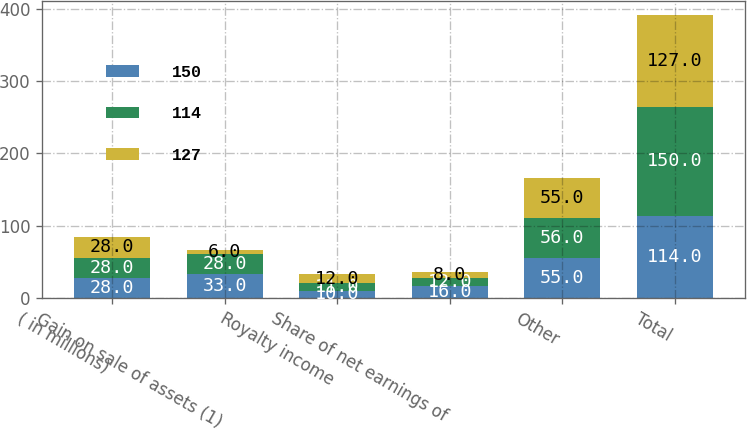Convert chart to OTSL. <chart><loc_0><loc_0><loc_500><loc_500><stacked_bar_chart><ecel><fcel>( in millions)<fcel>Gain on sale of assets (1)<fcel>Royalty income<fcel>Share of net earnings of<fcel>Other<fcel>Total<nl><fcel>150<fcel>28<fcel>33<fcel>10<fcel>16<fcel>55<fcel>114<nl><fcel>114<fcel>28<fcel>28<fcel>11<fcel>12<fcel>56<fcel>150<nl><fcel>127<fcel>28<fcel>6<fcel>12<fcel>8<fcel>55<fcel>127<nl></chart> 